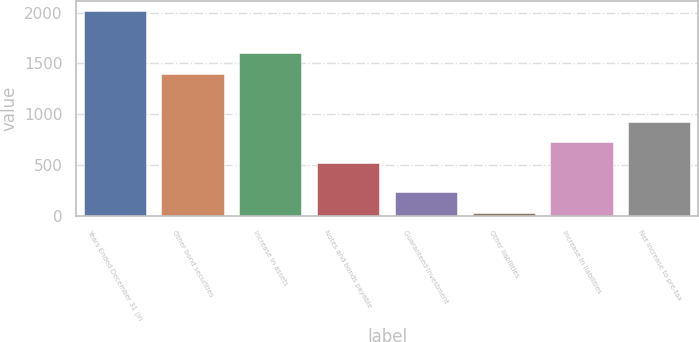<chart> <loc_0><loc_0><loc_500><loc_500><bar_chart><fcel>Years Ended December 31 (in<fcel>Other bond securities<fcel>Increase in assets<fcel>Notes and bonds payable<fcel>Guaranteed Investment<fcel>Other liabilities<fcel>Increase in liabilities<fcel>Net increase to pre-tax<nl><fcel>2012<fcel>1401<fcel>1598.8<fcel>526<fcel>231.8<fcel>34<fcel>723.8<fcel>921.6<nl></chart> 